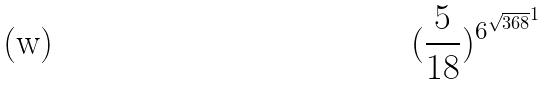<formula> <loc_0><loc_0><loc_500><loc_500>( \frac { 5 } { 1 8 } ) ^ { { 6 ^ { \sqrt { 3 6 8 } } } ^ { 1 } }</formula> 